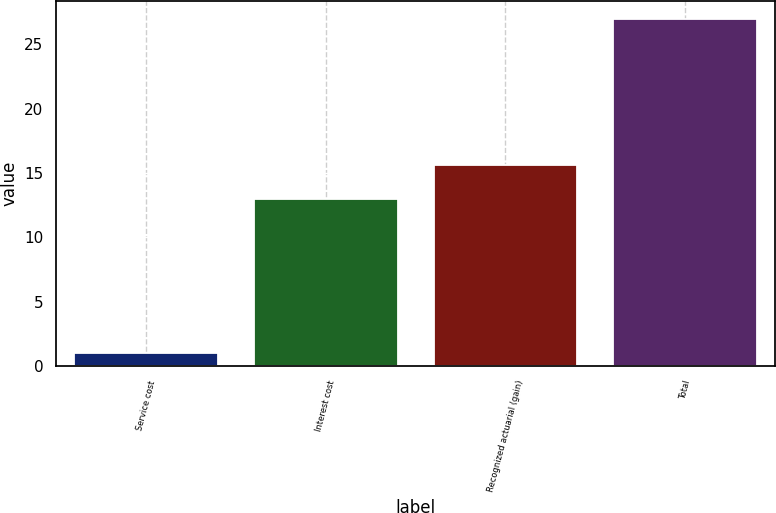Convert chart. <chart><loc_0><loc_0><loc_500><loc_500><bar_chart><fcel>Service cost<fcel>Interest cost<fcel>Recognized actuarial (gain)<fcel>Total<nl><fcel>1<fcel>13<fcel>15.6<fcel>27<nl></chart> 